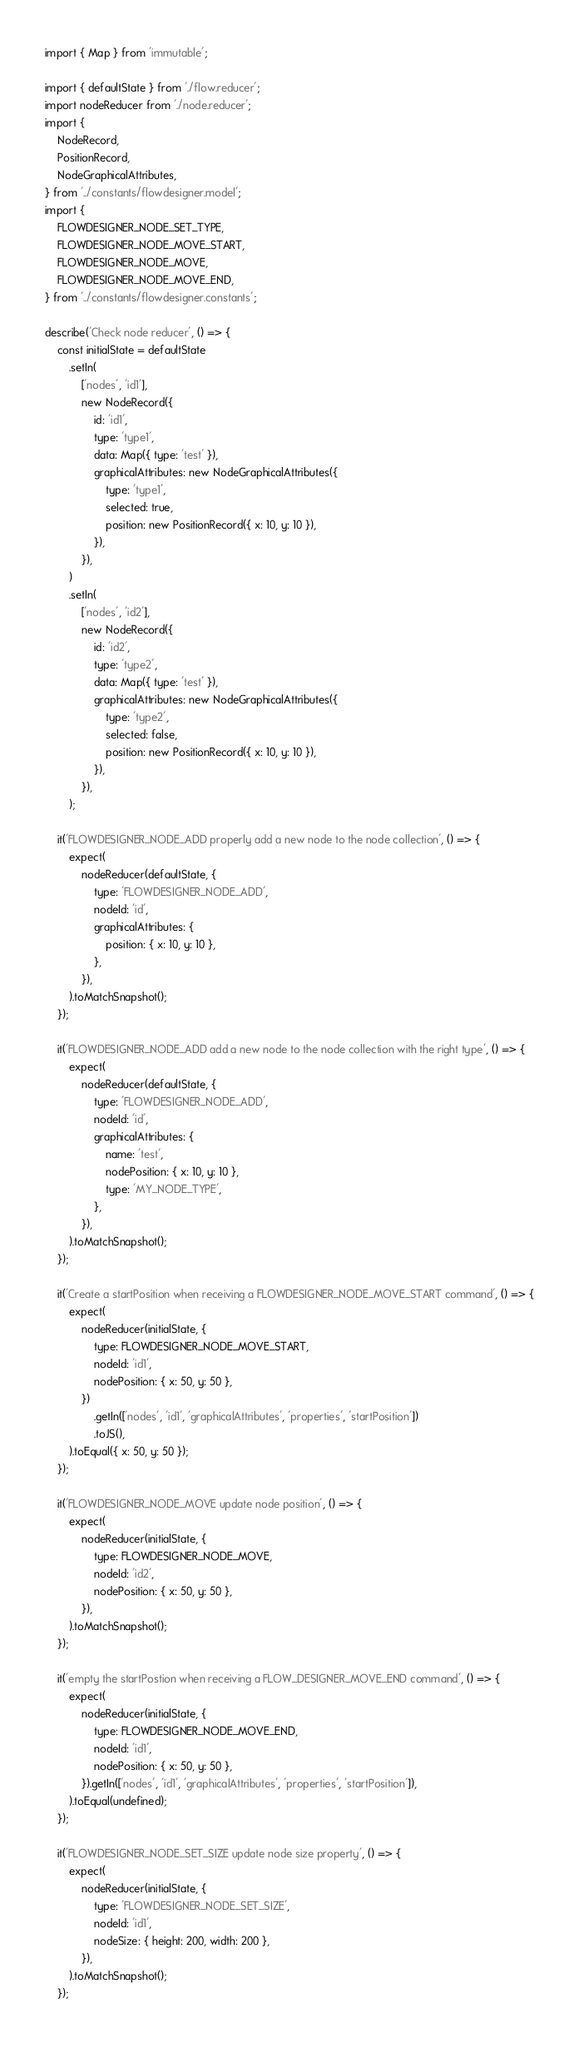Convert code to text. <code><loc_0><loc_0><loc_500><loc_500><_TypeScript_>import { Map } from 'immutable';

import { defaultState } from './flow.reducer';
import nodeReducer from './node.reducer';
import {
	NodeRecord,
	PositionRecord,
	NodeGraphicalAttributes,
} from '../constants/flowdesigner.model';
import {
	FLOWDESIGNER_NODE_SET_TYPE,
	FLOWDESIGNER_NODE_MOVE_START,
	FLOWDESIGNER_NODE_MOVE,
	FLOWDESIGNER_NODE_MOVE_END,
} from '../constants/flowdesigner.constants';

describe('Check node reducer', () => {
	const initialState = defaultState
		.setIn(
			['nodes', 'id1'],
			new NodeRecord({
				id: 'id1',
				type: 'type1',
				data: Map({ type: 'test' }),
				graphicalAttributes: new NodeGraphicalAttributes({
					type: 'type1',
					selected: true,
					position: new PositionRecord({ x: 10, y: 10 }),
				}),
			}),
		)
		.setIn(
			['nodes', 'id2'],
			new NodeRecord({
				id: 'id2',
				type: 'type2',
				data: Map({ type: 'test' }),
				graphicalAttributes: new NodeGraphicalAttributes({
					type: 'type2',
					selected: false,
					position: new PositionRecord({ x: 10, y: 10 }),
				}),
			}),
		);

	it('FLOWDESIGNER_NODE_ADD properly add a new node to the node collection', () => {
		expect(
			nodeReducer(defaultState, {
				type: 'FLOWDESIGNER_NODE_ADD',
				nodeId: 'id',
				graphicalAttributes: {
					position: { x: 10, y: 10 },
				},
			}),
		).toMatchSnapshot();
	});

	it('FLOWDESIGNER_NODE_ADD add a new node to the node collection with the right type', () => {
		expect(
			nodeReducer(defaultState, {
				type: 'FLOWDESIGNER_NODE_ADD',
				nodeId: 'id',
				graphicalAttributes: {
					name: 'test',
					nodePosition: { x: 10, y: 10 },
					type: 'MY_NODE_TYPE',
				},
			}),
		).toMatchSnapshot();
	});

	it('Create a startPosition when receiving a FLOWDESIGNER_NODE_MOVE_START command', () => {
		expect(
			nodeReducer(initialState, {
				type: FLOWDESIGNER_NODE_MOVE_START,
				nodeId: 'id1',
				nodePosition: { x: 50, y: 50 },
			})
				.getIn(['nodes', 'id1', 'graphicalAttributes', 'properties', 'startPosition'])
				.toJS(),
		).toEqual({ x: 50, y: 50 });
	});

	it('FLOWDESIGNER_NODE_MOVE update node position', () => {
		expect(
			nodeReducer(initialState, {
				type: FLOWDESIGNER_NODE_MOVE,
				nodeId: 'id2',
				nodePosition: { x: 50, y: 50 },
			}),
		).toMatchSnapshot();
	});

	it('empty the startPostion when receiving a FLOW_DESIGNER_MOVE_END command', () => {
		expect(
			nodeReducer(initialState, {
				type: FLOWDESIGNER_NODE_MOVE_END,
				nodeId: 'id1',
				nodePosition: { x: 50, y: 50 },
			}).getIn(['nodes', 'id1', 'graphicalAttributes', 'properties', 'startPosition']),
		).toEqual(undefined);
	});

	it('FLOWDESIGNER_NODE_SET_SIZE update node size property', () => {
		expect(
			nodeReducer(initialState, {
				type: 'FLOWDESIGNER_NODE_SET_SIZE',
				nodeId: 'id1',
				nodeSize: { height: 200, width: 200 },
			}),
		).toMatchSnapshot();
	});
</code> 